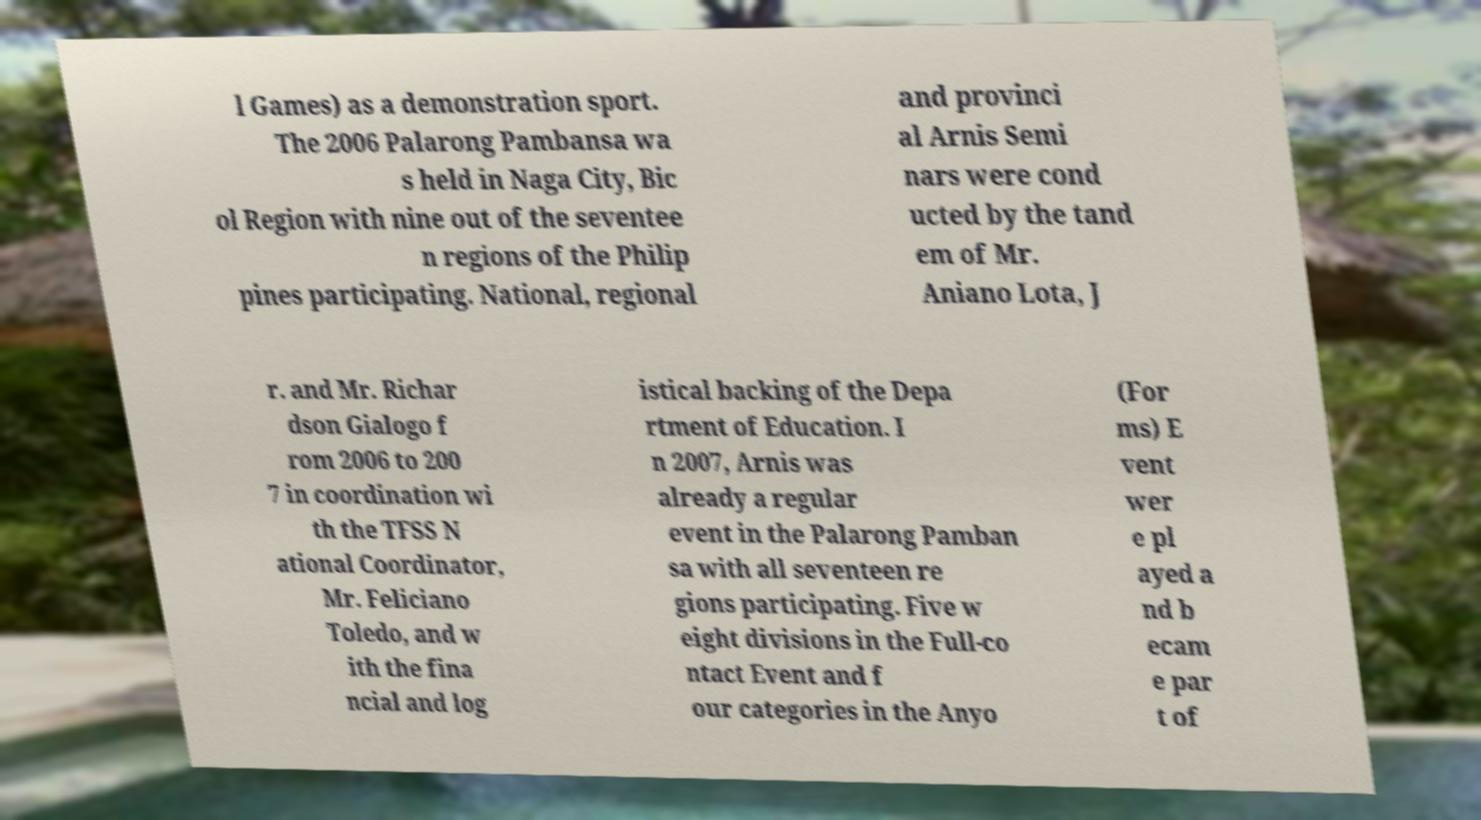Please identify and transcribe the text found in this image. l Games) as a demonstration sport. The 2006 Palarong Pambansa wa s held in Naga City, Bic ol Region with nine out of the seventee n regions of the Philip pines participating. National, regional and provinci al Arnis Semi nars were cond ucted by the tand em of Mr. Aniano Lota, J r. and Mr. Richar dson Gialogo f rom 2006 to 200 7 in coordination wi th the TFSS N ational Coordinator, Mr. Feliciano Toledo, and w ith the fina ncial and log istical backing of the Depa rtment of Education. I n 2007, Arnis was already a regular event in the Palarong Pamban sa with all seventeen re gions participating. Five w eight divisions in the Full-co ntact Event and f our categories in the Anyo (For ms) E vent wer e pl ayed a nd b ecam e par t of 